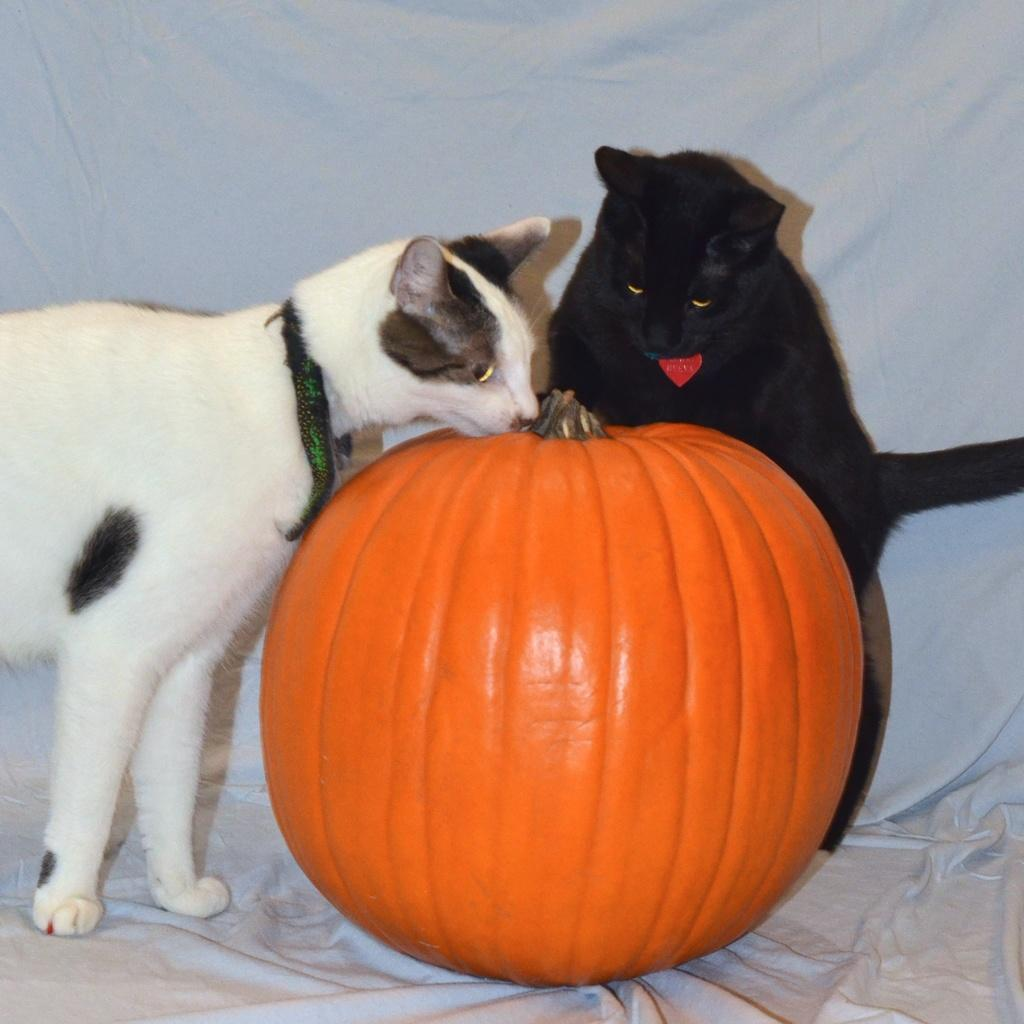How many cats can be seen in the image? There are two cats in the image. What object is also present in the image besides the cats? There is a pumpkin in the image. What can be seen in the background of the image? There is a curtain in the background of the image. What type of cork can be seen in the image? There is no cork present in the image. How many potatoes are visible in the image? There are no potatoes visible in the image. 